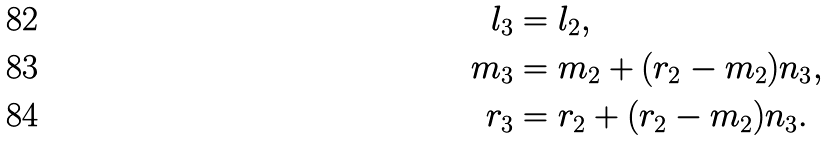<formula> <loc_0><loc_0><loc_500><loc_500>l _ { 3 } & = l _ { 2 } , \\ m _ { 3 } & = m _ { 2 } + ( r _ { 2 } - m _ { 2 } ) n _ { 3 } , \\ r _ { 3 } & = r _ { 2 } + ( r _ { 2 } - m _ { 2 } ) n _ { 3 } .</formula> 